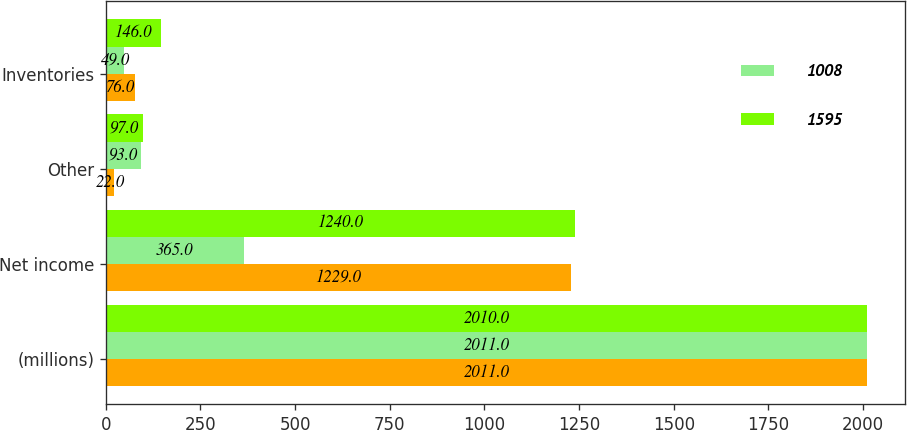<chart> <loc_0><loc_0><loc_500><loc_500><stacked_bar_chart><ecel><fcel>(millions)<fcel>Net income<fcel>Other<fcel>Inventories<nl><fcel>nan<fcel>2011<fcel>1229<fcel>22<fcel>76<nl><fcel>1008<fcel>2011<fcel>365<fcel>93<fcel>49<nl><fcel>1595<fcel>2010<fcel>1240<fcel>97<fcel>146<nl></chart> 